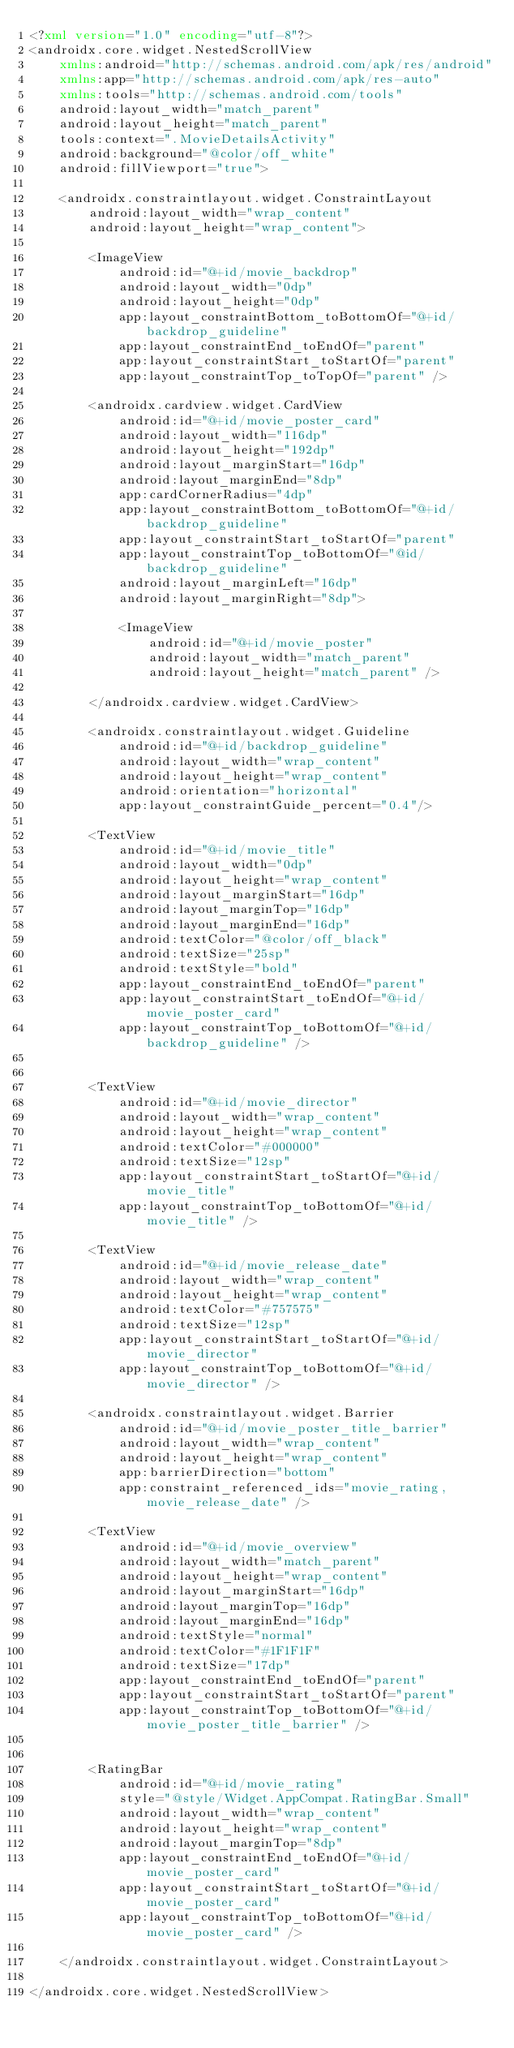<code> <loc_0><loc_0><loc_500><loc_500><_XML_><?xml version="1.0" encoding="utf-8"?>
<androidx.core.widget.NestedScrollView
    xmlns:android="http://schemas.android.com/apk/res/android"
    xmlns:app="http://schemas.android.com/apk/res-auto"
    xmlns:tools="http://schemas.android.com/tools"
    android:layout_width="match_parent"
    android:layout_height="match_parent"
    tools:context=".MovieDetailsActivity"
    android:background="@color/off_white"
    android:fillViewport="true">

    <androidx.constraintlayout.widget.ConstraintLayout
        android:layout_width="wrap_content"
        android:layout_height="wrap_content">

        <ImageView
            android:id="@+id/movie_backdrop"
            android:layout_width="0dp"
            android:layout_height="0dp"
            app:layout_constraintBottom_toBottomOf="@+id/backdrop_guideline"
            app:layout_constraintEnd_toEndOf="parent"
            app:layout_constraintStart_toStartOf="parent"
            app:layout_constraintTop_toTopOf="parent" />

        <androidx.cardview.widget.CardView
            android:id="@+id/movie_poster_card"
            android:layout_width="116dp"
            android:layout_height="192dp"
            android:layout_marginStart="16dp"
            android:layout_marginEnd="8dp"
            app:cardCornerRadius="4dp"
            app:layout_constraintBottom_toBottomOf="@+id/backdrop_guideline"
            app:layout_constraintStart_toStartOf="parent"
            app:layout_constraintTop_toBottomOf="@id/backdrop_guideline"
            android:layout_marginLeft="16dp"
            android:layout_marginRight="8dp">

            <ImageView
                android:id="@+id/movie_poster"
                android:layout_width="match_parent"
                android:layout_height="match_parent" />

        </androidx.cardview.widget.CardView>

        <androidx.constraintlayout.widget.Guideline
            android:id="@+id/backdrop_guideline"
            android:layout_width="wrap_content"
            android:layout_height="wrap_content"
            android:orientation="horizontal"
            app:layout_constraintGuide_percent="0.4"/>

        <TextView
            android:id="@+id/movie_title"
            android:layout_width="0dp"
            android:layout_height="wrap_content"
            android:layout_marginStart="16dp"
            android:layout_marginTop="16dp"
            android:layout_marginEnd="16dp"
            android:textColor="@color/off_black"
            android:textSize="25sp"
            android:textStyle="bold"
            app:layout_constraintEnd_toEndOf="parent"
            app:layout_constraintStart_toEndOf="@+id/movie_poster_card"
            app:layout_constraintTop_toBottomOf="@+id/backdrop_guideline" />


        <TextView
            android:id="@+id/movie_director"
            android:layout_width="wrap_content"
            android:layout_height="wrap_content"
            android:textColor="#000000"
            android:textSize="12sp"
            app:layout_constraintStart_toStartOf="@+id/movie_title"
            app:layout_constraintTop_toBottomOf="@+id/movie_title" />

        <TextView
            android:id="@+id/movie_release_date"
            android:layout_width="wrap_content"
            android:layout_height="wrap_content"
            android:textColor="#757575"
            android:textSize="12sp"
            app:layout_constraintStart_toStartOf="@+id/movie_director"
            app:layout_constraintTop_toBottomOf="@+id/movie_director" />

        <androidx.constraintlayout.widget.Barrier
            android:id="@+id/movie_poster_title_barrier"
            android:layout_width="wrap_content"
            android:layout_height="wrap_content"
            app:barrierDirection="bottom"
            app:constraint_referenced_ids="movie_rating,movie_release_date" />

        <TextView
            android:id="@+id/movie_overview"
            android:layout_width="match_parent"
            android:layout_height="wrap_content"
            android:layout_marginStart="16dp"
            android:layout_marginTop="16dp"
            android:layout_marginEnd="16dp"
            android:textStyle="normal"
            android:textColor="#1F1F1F"
            android:textSize="17dp"
            app:layout_constraintEnd_toEndOf="parent"
            app:layout_constraintStart_toStartOf="parent"
            app:layout_constraintTop_toBottomOf="@+id/movie_poster_title_barrier" />


        <RatingBar
            android:id="@+id/movie_rating"
            style="@style/Widget.AppCompat.RatingBar.Small"
            android:layout_width="wrap_content"
            android:layout_height="wrap_content"
            android:layout_marginTop="8dp"
            app:layout_constraintEnd_toEndOf="@+id/movie_poster_card"
            app:layout_constraintStart_toStartOf="@+id/movie_poster_card"
            app:layout_constraintTop_toBottomOf="@+id/movie_poster_card" />

    </androidx.constraintlayout.widget.ConstraintLayout>

</androidx.core.widget.NestedScrollView></code> 